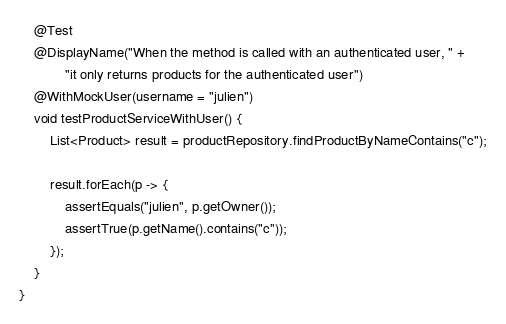<code> <loc_0><loc_0><loc_500><loc_500><_Java_>
    @Test
    @DisplayName("When the method is called with an authenticated user, " +
            "it only returns products for the authenticated user")
    @WithMockUser(username = "julien")
    void testProductServiceWithUser() {
        List<Product> result = productRepository.findProductByNameContains("c");

        result.forEach(p -> {
            assertEquals("julien", p.getOwner());
            assertTrue(p.getName().contains("c"));
        });
    }
}
</code> 